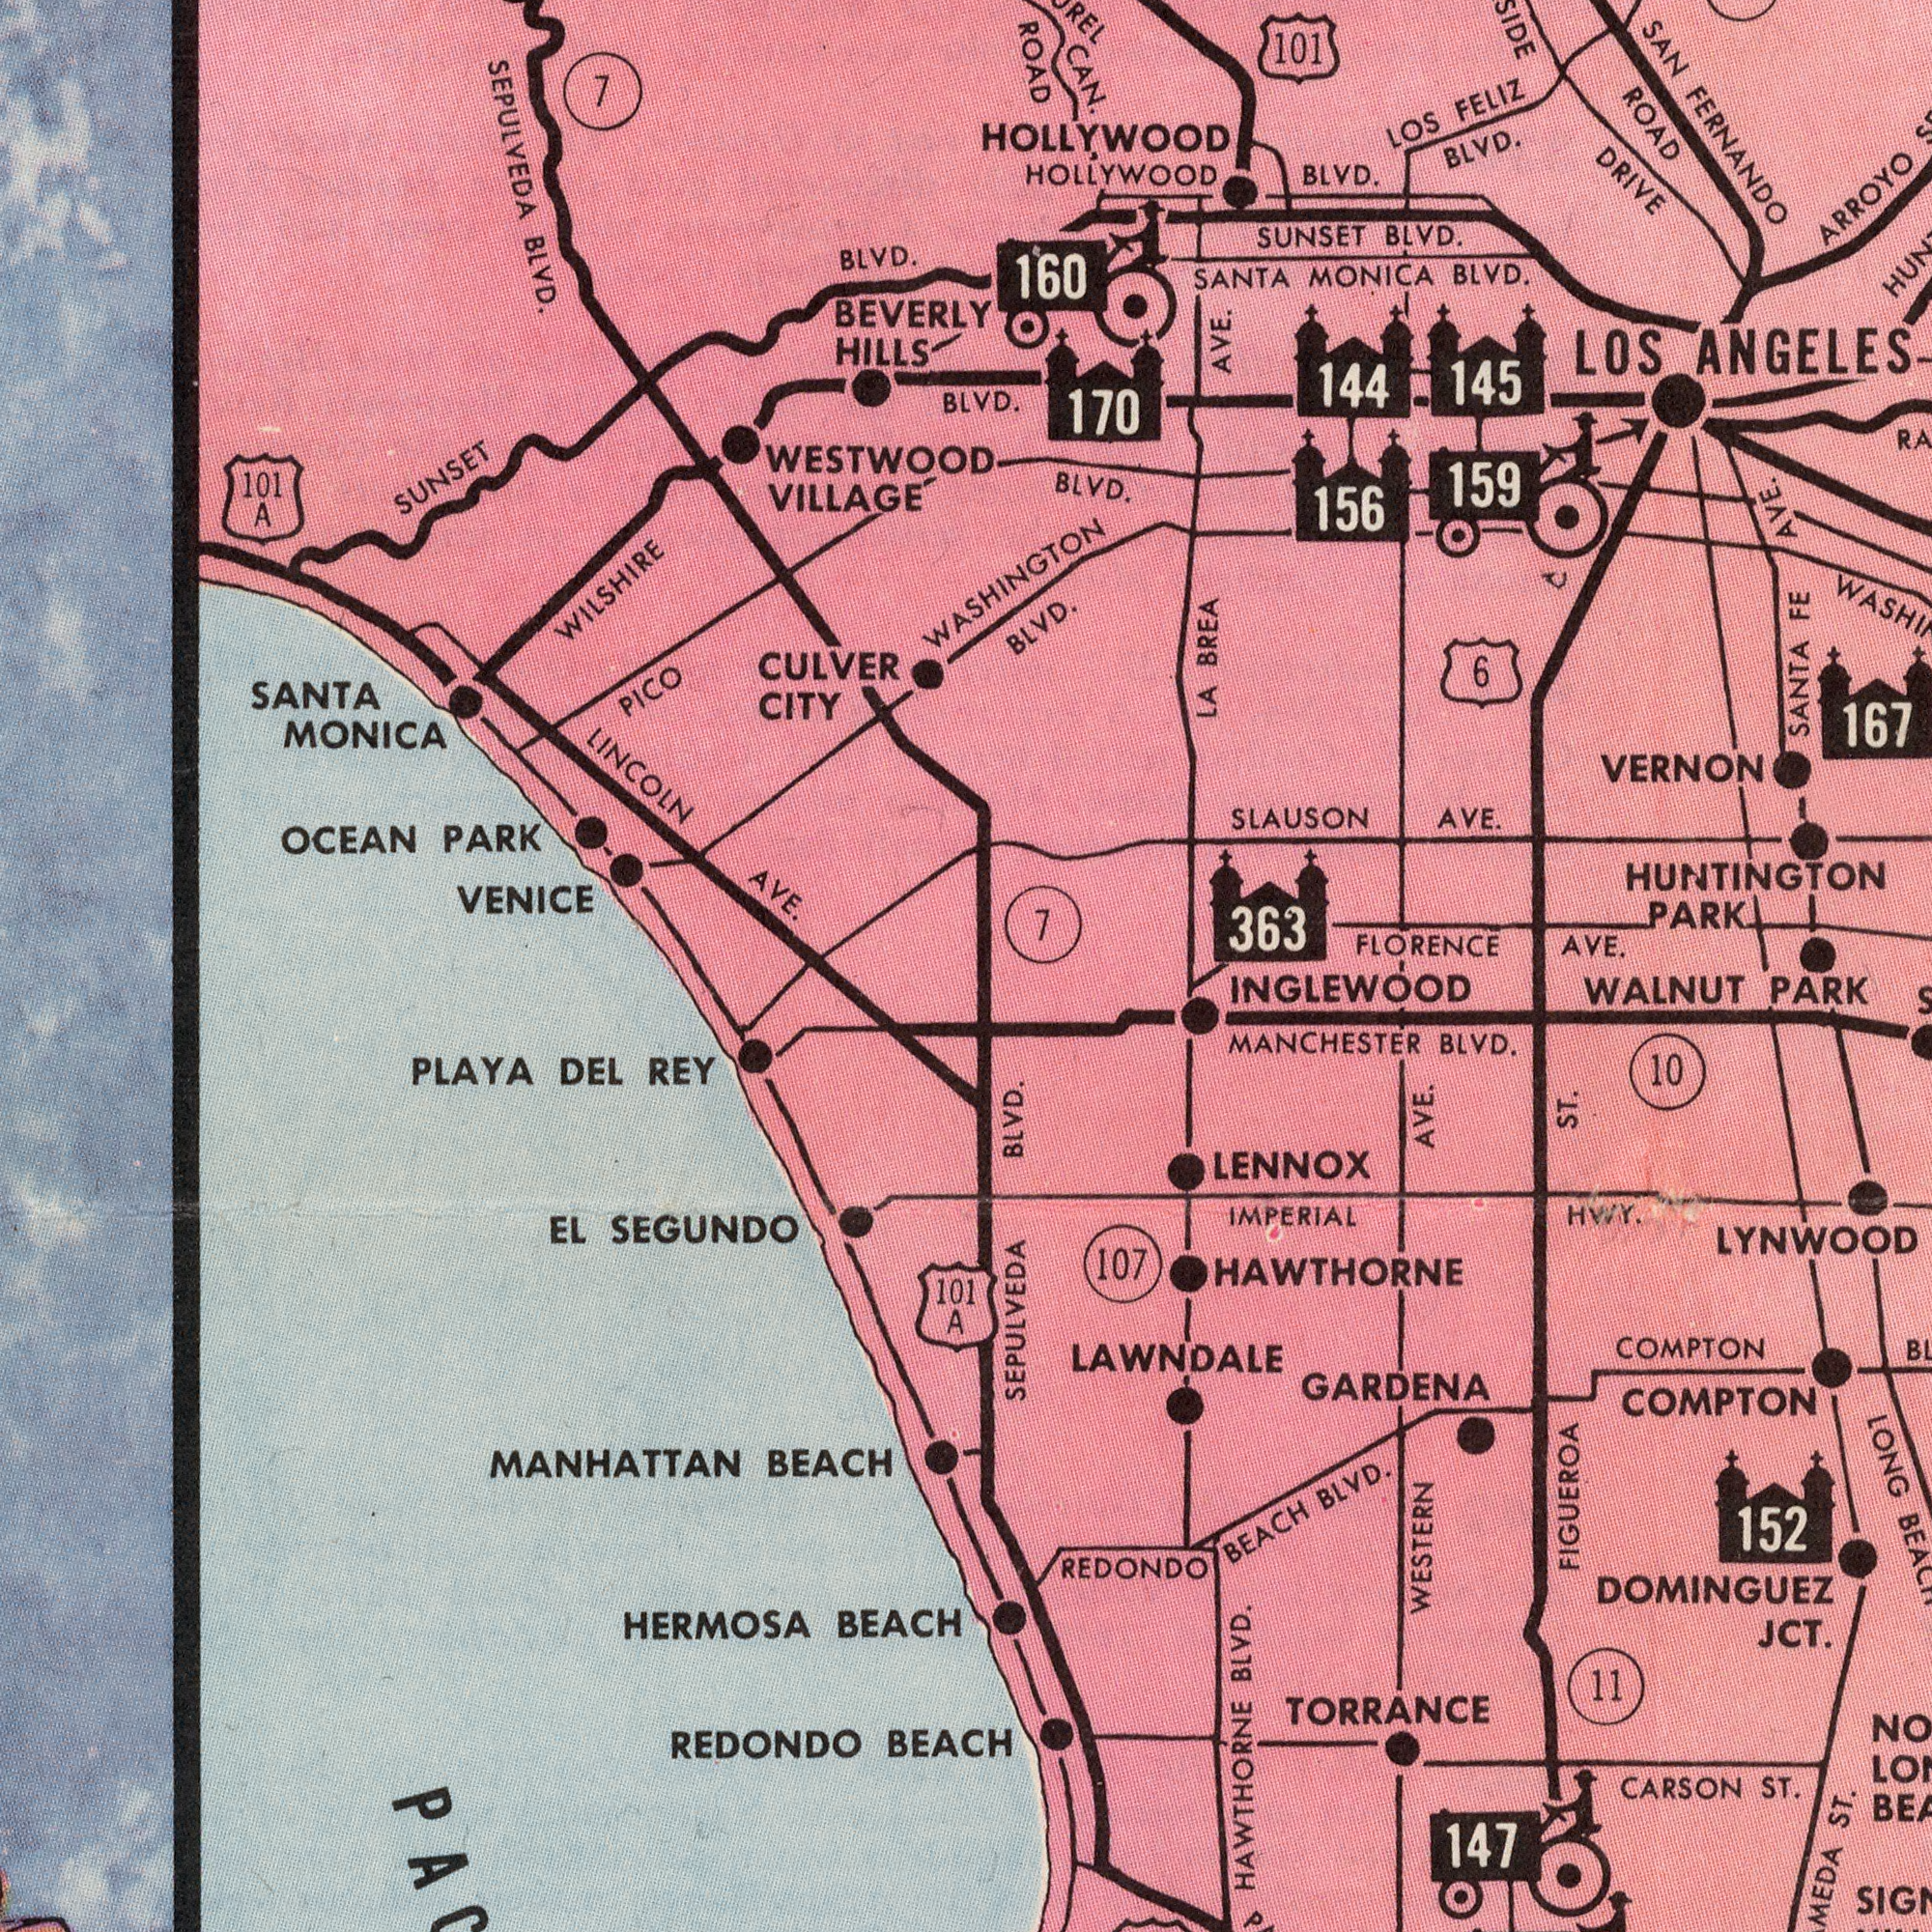What text is shown in the bottom-left quadrant? MANHATTAN SEGUNDO BEACH BEACH DEL REY PLAYA BEACH EL HERMOSA 101 REDONDO A BLVD. SEPULVEDA What text is visible in the upper-left corner? SEPULVEDA VILLAGE OCEAN BEVERLY 7 VENICE PARK BLVD. AVE. SUNSET HILLS WESTWOOD BLVD. MONICA PICO CITY 101 LINCOLN CULVER WILSHIRE A SANTA 7 BLVD. BLVD. 160 ROAD WASHINGTON What text appears in the top-right area of the image? FERNANDO ANGELES VERNON PARK AVE. SANTA ARROYO BLVD. AVE. 363 LA BLVD. BLVD. BLVD. HUNTINGTON HOLLYWOOD SANTA SAN CAN. FELIZ 101 SUNSET HOLLYWOOD LOS MONICA LOS AVE. SLAUSON FE 170 156 BREA AVE. 159 145 6 ROAD BLVD. DRIVE 167 144 FLORENCE C What text appears in the bottom-right area of the image? TORRANCE COMPTON COMPTON MANCHESTER GARDENA ST. FIGUEROA LENNOX LONG WALNUT PARK CARSON WESTERN ST. REDONDO ST. BLVD. BLVD. BEACH IMPERIAL HWY. 10 JCT. INGLEWOOD BLVD. 107 11 HAWTHORNE HAWTHORNE LAWNDALE LYNWOOD AVE. DOMINGUEZ 147 152 